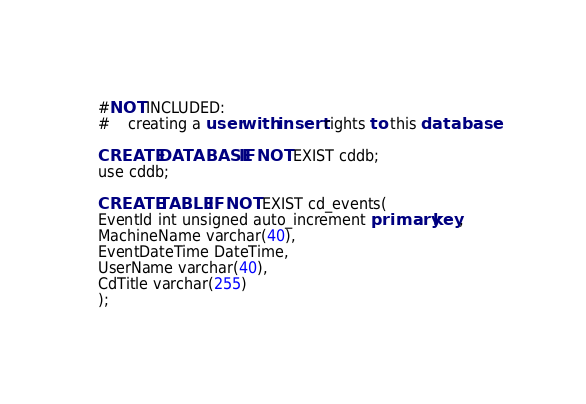Convert code to text. <code><loc_0><loc_0><loc_500><loc_500><_SQL_>#NOT INCLUDED: 
#	creating a user with insert rights to this database

CREATE DATABASE IF NOT EXIST cddb;
use cddb;

CREATE TABLE IF NOT EXIST cd_events(
EventId int unsigned auto_increment primary key,
MachineName varchar(40),
EventDateTime DateTime,
UserName varchar(40),
CdTitle varchar(255)
);

</code> 